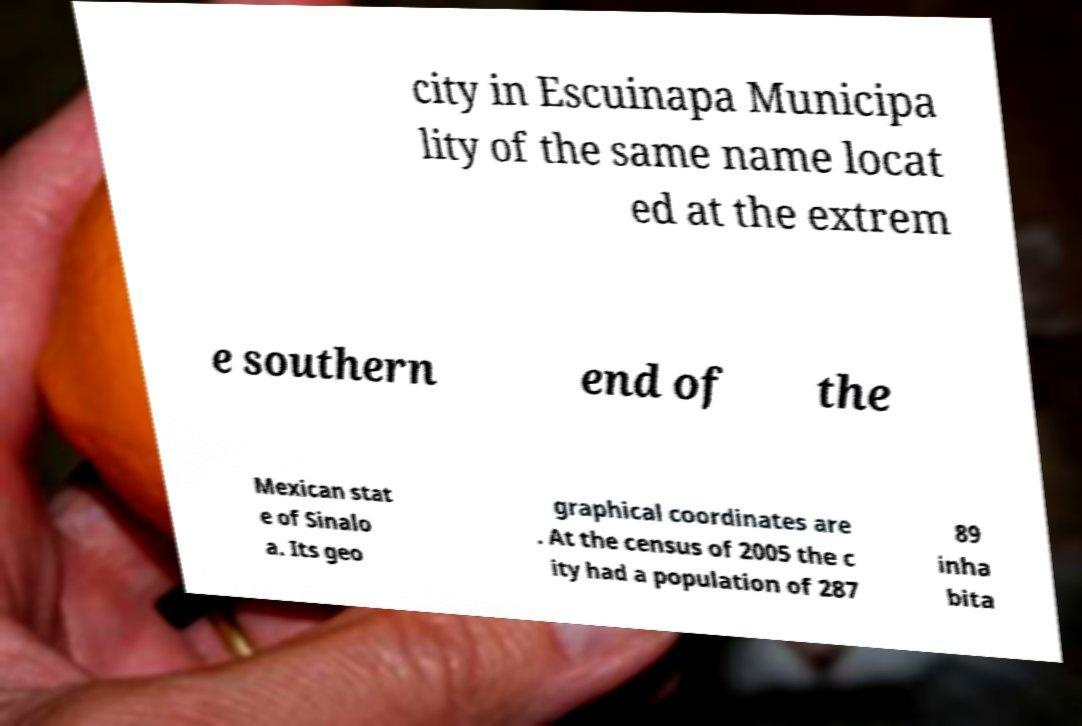Could you assist in decoding the text presented in this image and type it out clearly? city in Escuinapa Municipa lity of the same name locat ed at the extrem e southern end of the Mexican stat e of Sinalo a. Its geo graphical coordinates are . At the census of 2005 the c ity had a population of 287 89 inha bita 